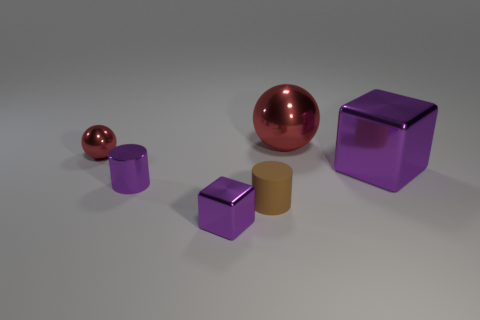Add 3 big blue spheres. How many objects exist? 9 Subtract all cylinders. How many objects are left? 4 Add 2 large spheres. How many large spheres are left? 3 Add 3 tiny purple blocks. How many tiny purple blocks exist? 4 Subtract 0 green spheres. How many objects are left? 6 Subtract all rubber things. Subtract all metal cylinders. How many objects are left? 4 